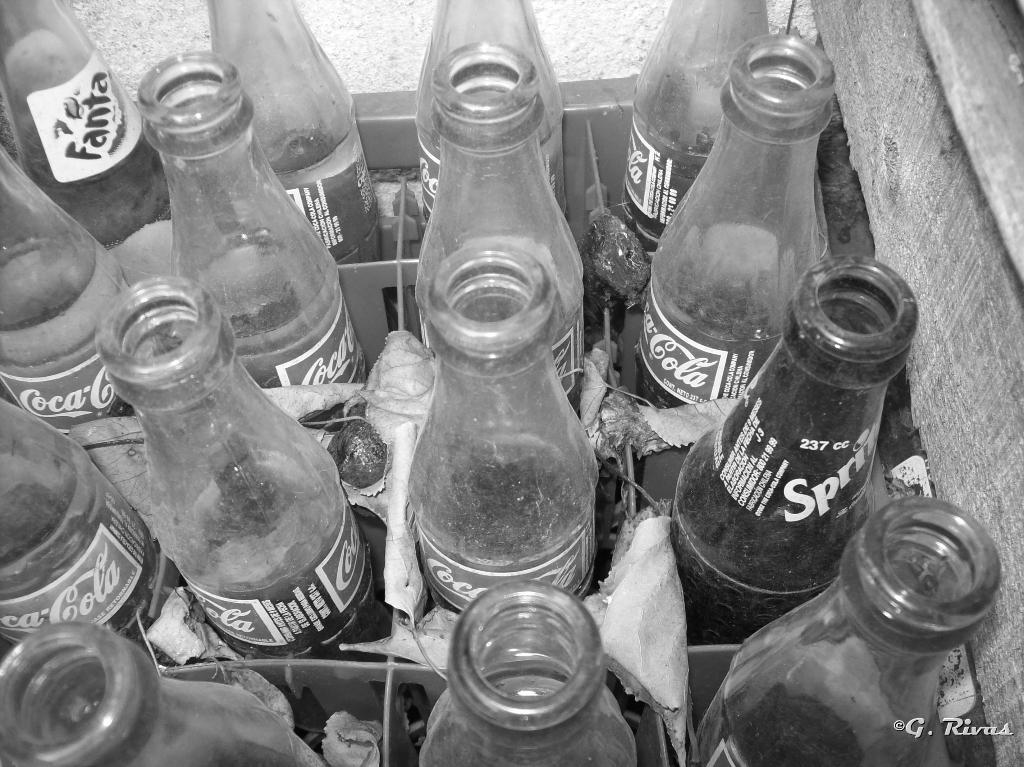What is the main object in the image? There is a stand in the image. What is placed on the stand? Bottles are arranged on the stand. How does the person in the image show respect for the edge of the stand? There is no person present in the image, so it is not possible to determine how they might show respect for the edge of the stand. 